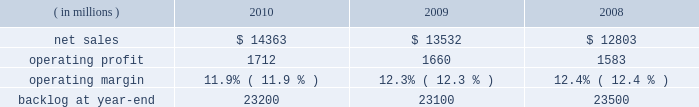Operating profit for the segment increased 10% ( 10 % ) in 2009 compared to 2008 .
The growth in operating profit primarily was due to increases in air mobility and other aeronautics programs .
The $ 70 million increase in air mobility 2019s operating profit primarily was due to the higher volume on c-130j deliveries and c-130 support programs .
In other aeronautics programs , operating profit increased $ 120 million , which mainly was attributable to improved performance in sustainment activities and higher volume on p-3 programs .
Additionally , the increase in operating profit included the favorable restructuring of a p-3 modification contract in 2009 .
Combat aircraft 2019s operating profit decreased $ 22 million during the year primarily due to a reduction in the level of favorable performance adjustments on f-16 programs in 2009 compared to 2008 and lower volume on other combat aircraft programs .
These decreases more than offset increased operating profit resulting from higher volume and improved performance on the f-35 program and an increase in the level of favorable performance adjustments on the f-22 program in 2009 compared to 2008 .
The remaining change in operating profit is attributable to a decrease in other income , net , between the comparable periods .
Backlog increased in 2010 compared to 2009 mainly due to orders exceeding sales on the c-130j , f-35 and c-5 programs , which partially were offset by higher sales volume compared to new orders on the f-22 program in 2010 .
Backlog decreased in 2009 compared to 2008 mainly due to sales exceeding orders on the f-22 and f-35 programs , which partially were offset by orders exceeding sales on the c-130j and c-5 programs .
We expect aeronautics will have sales growth in the upper single digit percentage range for 2011 as compared to 2010 .
This increase primarily is driven by growth on f-35 low rate initial production ( lrip ) contracts , c-130j and c-5 rerp programs that will more than offset a decline on the f-22 program .
Operating profit is projected to increase at a mid single digit percentage rate above 2010 levels , resulting in a decline in operating margins between the years .
Similar to the relationship of operating margins from 2009 to 2010 discussed above , the expected operating margin decrease from 2010 to 2011 reflects the trend of aeronautics performing more development and initial production work on the f-35 program and is performing less work on more mature programs such as the f-22 and f-16 , even though sales are expected to increase in 2011 relative to 2010 .
Electronic systems our electronic systems business segment manages complex programs and designs , develops , produces , and integrates hardware and software solutions to ensure the mission readiness of armed forces and government agencies worldwide .
The segment 2019s three lines of business are mission systems & sensors ( ms2 ) , missiles & fire control ( m&fc ) , and global training & logistics ( gt&l ) .
With such a broad portfolio of programs to provide products and services , many of its activities involve a combination of both development and production contracts with varying delivery schedules .
Some of its more significant programs , including the thaad system , the aegis weapon system , and the littoral combat ship program , demonstrate the diverse products and services electronic systems provides .
Electronic systems 2019 operating results included the following : ( in millions ) 2010 2009 2008 .
Net sales for electronic systems increased by 6% ( 6 % ) in 2010 compared to 2009 .
Sales increased in all three lines of business during the year .
The $ 421 million increase at gt&l primarily was due to growth on readiness and stability operations , which partially was offset by lower volume on simulation & training programs .
The $ 316 million increase at m&fc primarily was due to higher volume on tactical missile and air defense programs , which partially was offset by a decline in volume on fire control systems .
The $ 94 million increase at ms2 mainly was due to higher volume on surface naval warfare , ship & aviation systems , and radar systems programs , which partially was offset by lower volume on undersea warfare programs .
Net sales for electronic systems increased by 6% ( 6 % ) in 2009 compared to 2008 .
Sales increases in m&fc and gt&l more than offset a decline in ms2 .
The $ 429 million increase in sales at m&fc primarily was due to growth on tactical missile programs and fire control systems .
The $ 355 million increase at gt&l primarily was due to growth on simulation and training activities and readiness and stability operations .
The increase in simulation and training also included sales from the first quarter 2009 acquisition of universal systems and technology , inc .
The $ 55 million decrease at ms2 mainly was due to lower volume on ship & aviation systems and undersea warfare programs , which partially were offset by higher volume on radar systems and surface naval warfare programs. .
What is the growth rate in the net sales from 2008 to 2009? 
Computations: ((13532 - 12803) / 12803)
Answer: 0.05694. 